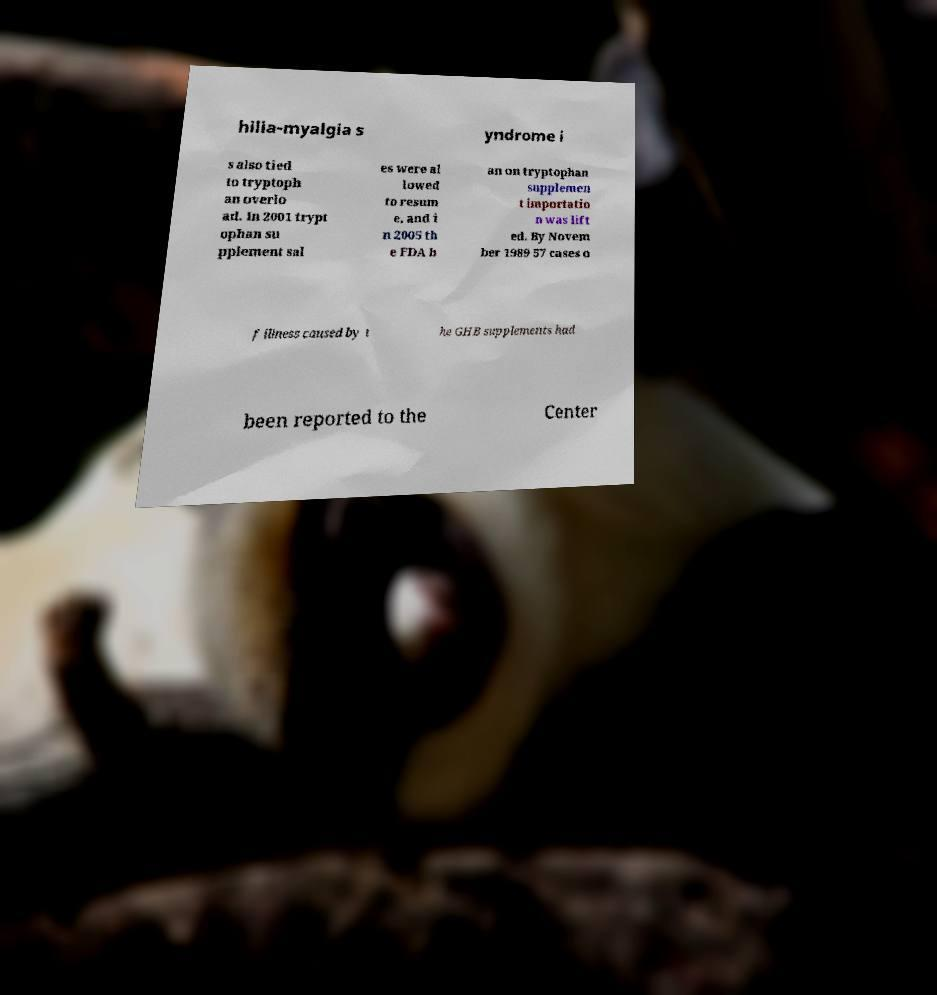There's text embedded in this image that I need extracted. Can you transcribe it verbatim? hilia-myalgia s yndrome i s also tied to tryptoph an overlo ad. In 2001 trypt ophan su pplement sal es were al lowed to resum e, and i n 2005 th e FDA b an on tryptophan supplemen t importatio n was lift ed. By Novem ber 1989 57 cases o f illness caused by t he GHB supplements had been reported to the Center 